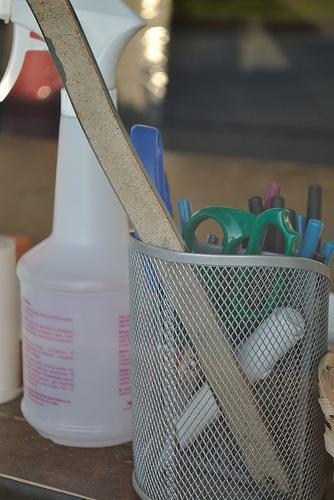How many visible ink pens?
Give a very brief answer. 11. 